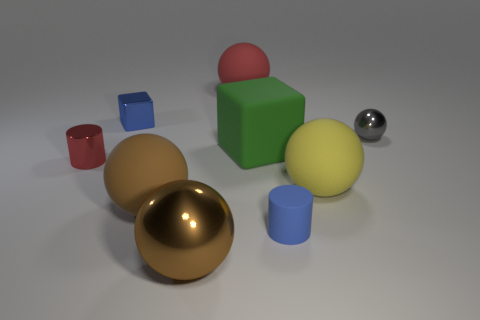Add 1 green matte objects. How many objects exist? 10 Subtract all big yellow balls. How many balls are left? 4 Subtract all spheres. How many objects are left? 4 Subtract 1 cylinders. How many cylinders are left? 1 Subtract all yellow balls. Subtract all green cylinders. How many balls are left? 4 Subtract all purple balls. How many blue cylinders are left? 1 Subtract all large cyan cylinders. Subtract all blue cubes. How many objects are left? 8 Add 5 blue metal objects. How many blue metal objects are left? 6 Add 6 gray matte balls. How many gray matte balls exist? 6 Subtract all yellow balls. How many balls are left? 4 